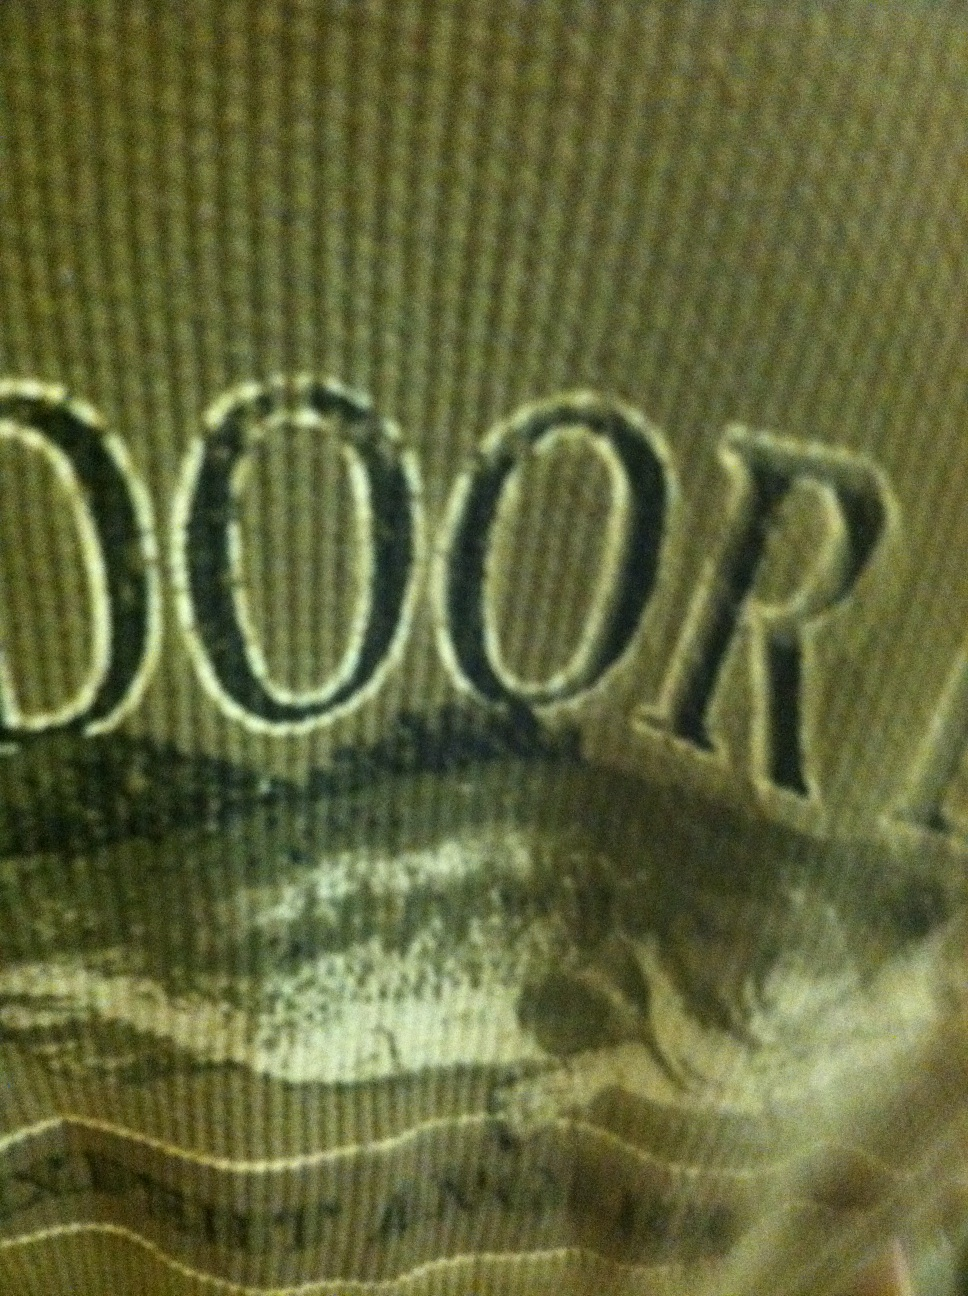What if this shirt had mystical powers? Describe its abilities. What if this green shirt possessed mystical powers? When worn, it could grant the wearer extraordinary abilities akin to nature itself. The shirt could enable one to communicate with animals, understand the whispers of the wind, and predict weather patterns with uncanny accuracy. It could allow the wearer to blend seamlessly into their surroundings, becoming nearly invisible in green landscapes, making it the ultimate garment for an adventurer exploring uncharted territories. 